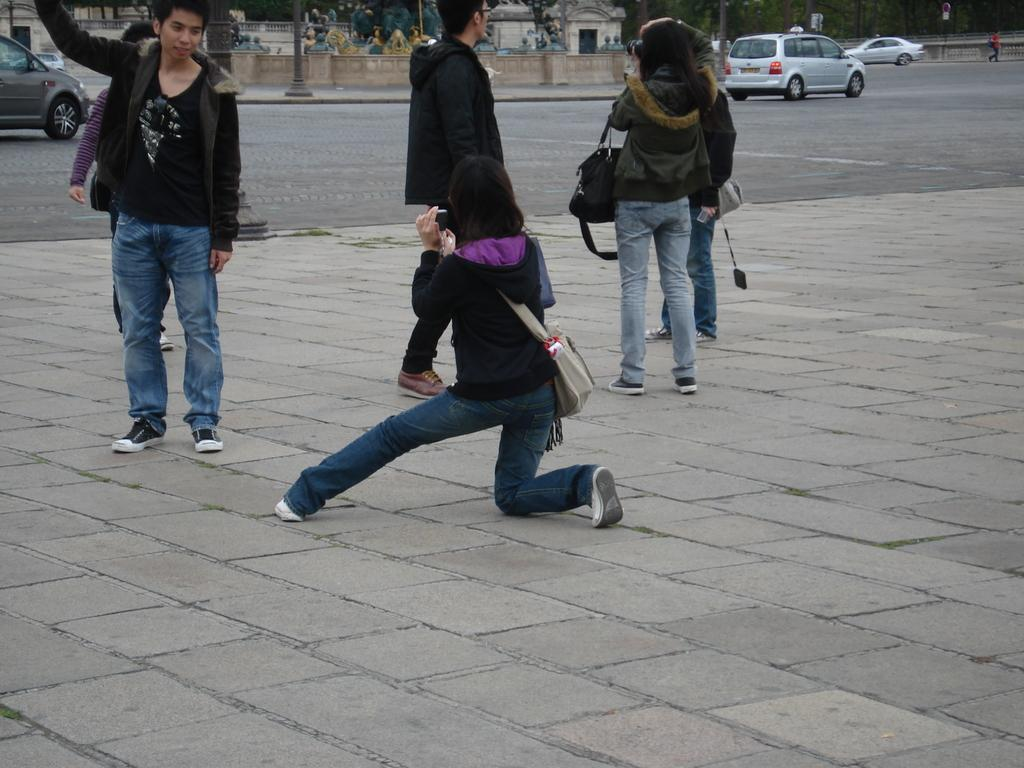What are the people in the image wearing? The persons in the image are wearing clothes. What can be seen on the road in the image? There are cars on the road in the image. What is located at the top of the image? There is a wall and a pole at the top of the image. How does the earthquake affect the wall and pole in the image? There is no earthquake present in the image, so its effects cannot be observed. 